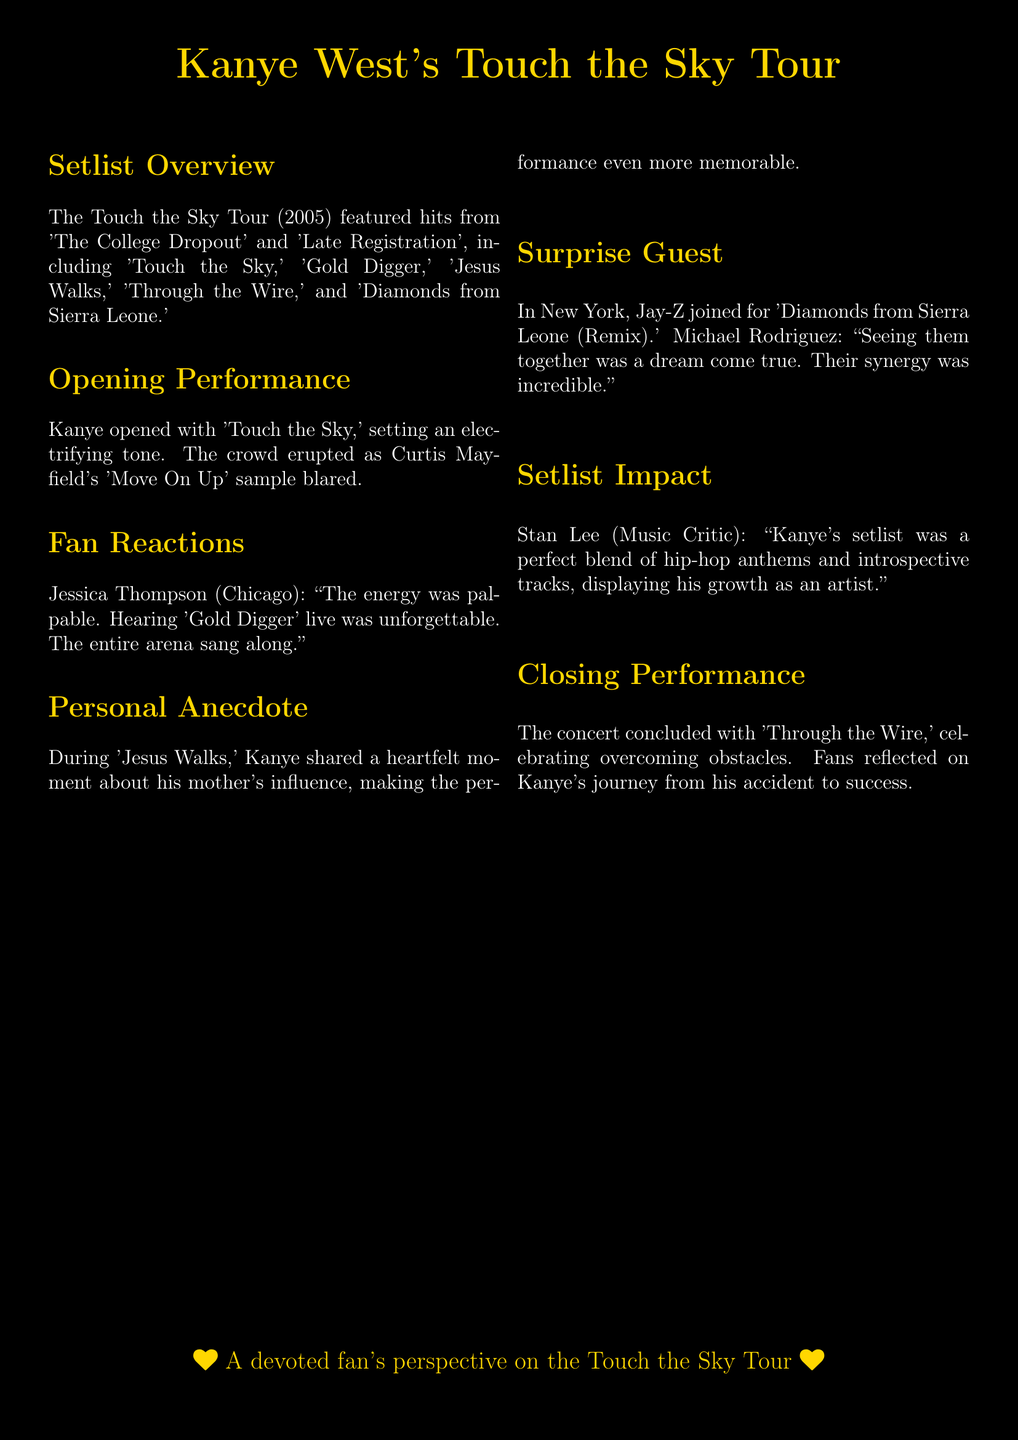What was the name of the tour? The tour is titled "Touch the Sky Tour."
Answer: Touch the Sky Tour What year did the Touch the Sky Tour take place? The tour took place in the year 2005.
Answer: 2005 Which song opened the concert? The opening performance was 'Touch the Sky.'
Answer: Touch the Sky Who made a surprise guest appearance during the tour? Jay-Z was a surprise guest in New York.
Answer: Jay-Z What is one song mentioned in the setlist? The setlist featured multiple songs, one being 'Gold Digger.'
Answer: Gold Digger What did Kanye West share during 'Jesus Walks'? He shared a heartfelt moment about his mother's influence.
Answer: His mother's influence How did fans react to hearing 'Gold Digger' live? Fans found hearing 'Gold Digger' live unforgettable and sang along.
Answer: Unforgettable Which song concluded the concert? The concert concluded with 'Through the Wire.'
Answer: Through the Wire Who commented on Kanye's setlist as a music critic? The music critic's name was Stan Lee.
Answer: Stan Lee What was the atmosphere like when Kanye opened the concert? The atmosphere was described as electrifying with a palpable energy.
Answer: Electrifying 